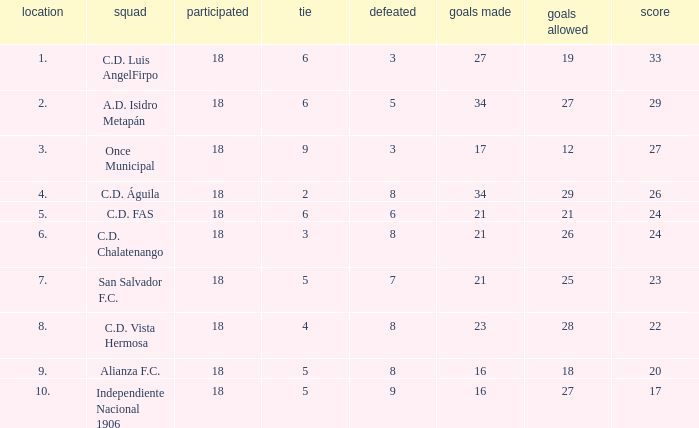What is the lowest amount of goals scored that has more than 19 goal conceded and played less than 18? None. Parse the table in full. {'header': ['location', 'squad', 'participated', 'tie', 'defeated', 'goals made', 'goals allowed', 'score'], 'rows': [['1.', 'C.D. Luis AngelFirpo', '18', '6', '3', '27', '19', '33'], ['2.', 'A.D. Isidro Metapán', '18', '6', '5', '34', '27', '29'], ['3.', 'Once Municipal', '18', '9', '3', '17', '12', '27'], ['4.', 'C.D. Águila', '18', '2', '8', '34', '29', '26'], ['5.', 'C.D. FAS', '18', '6', '6', '21', '21', '24'], ['6.', 'C.D. Chalatenango', '18', '3', '8', '21', '26', '24'], ['7.', 'San Salvador F.C.', '18', '5', '7', '21', '25', '23'], ['8.', 'C.D. Vista Hermosa', '18', '4', '8', '23', '28', '22'], ['9.', 'Alianza F.C.', '18', '5', '8', '16', '18', '20'], ['10.', 'Independiente Nacional 1906', '18', '5', '9', '16', '27', '17']]} 